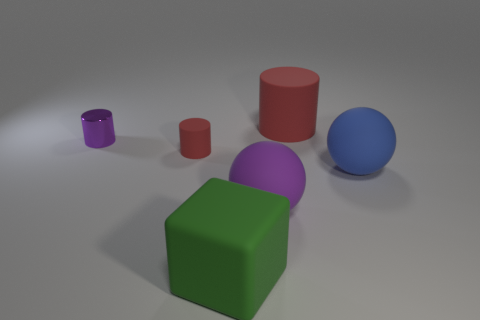Subtract all tiny shiny cylinders. How many cylinders are left? 2 Subtract all gray blocks. How many red cylinders are left? 2 Subtract all purple cylinders. How many cylinders are left? 2 Add 4 shiny blocks. How many objects exist? 10 Subtract all gray cylinders. Subtract all yellow balls. How many cylinders are left? 3 Add 3 small shiny cylinders. How many small shiny cylinders exist? 4 Subtract 1 blue balls. How many objects are left? 5 Subtract all cubes. How many objects are left? 5 Subtract all red objects. Subtract all large blue objects. How many objects are left? 3 Add 3 red rubber cylinders. How many red rubber cylinders are left? 5 